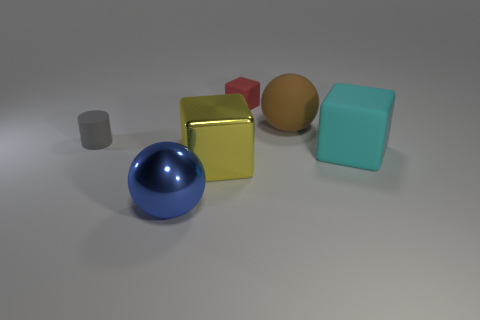What is the size of the red block?
Ensure brevity in your answer.  Small. How many matte cubes are the same size as the blue shiny ball?
Keep it short and to the point. 1. What is the material of the other large object that is the same shape as the large cyan rubber thing?
Ensure brevity in your answer.  Metal. What is the shape of the thing that is left of the cyan block and on the right side of the small red thing?
Give a very brief answer. Sphere. What shape is the small thing to the left of the shiny sphere?
Provide a succinct answer. Cylinder. How many objects are both in front of the red matte cube and left of the brown sphere?
Provide a succinct answer. 3. Do the brown matte thing and the sphere that is in front of the big cyan object have the same size?
Provide a short and direct response. Yes. What size is the sphere behind the large cube to the right of the rubber cube that is behind the big cyan object?
Make the answer very short. Large. There is a matte cube in front of the large brown object; what size is it?
Offer a terse response. Large. What is the shape of the big thing that is made of the same material as the large cyan cube?
Offer a terse response. Sphere. 